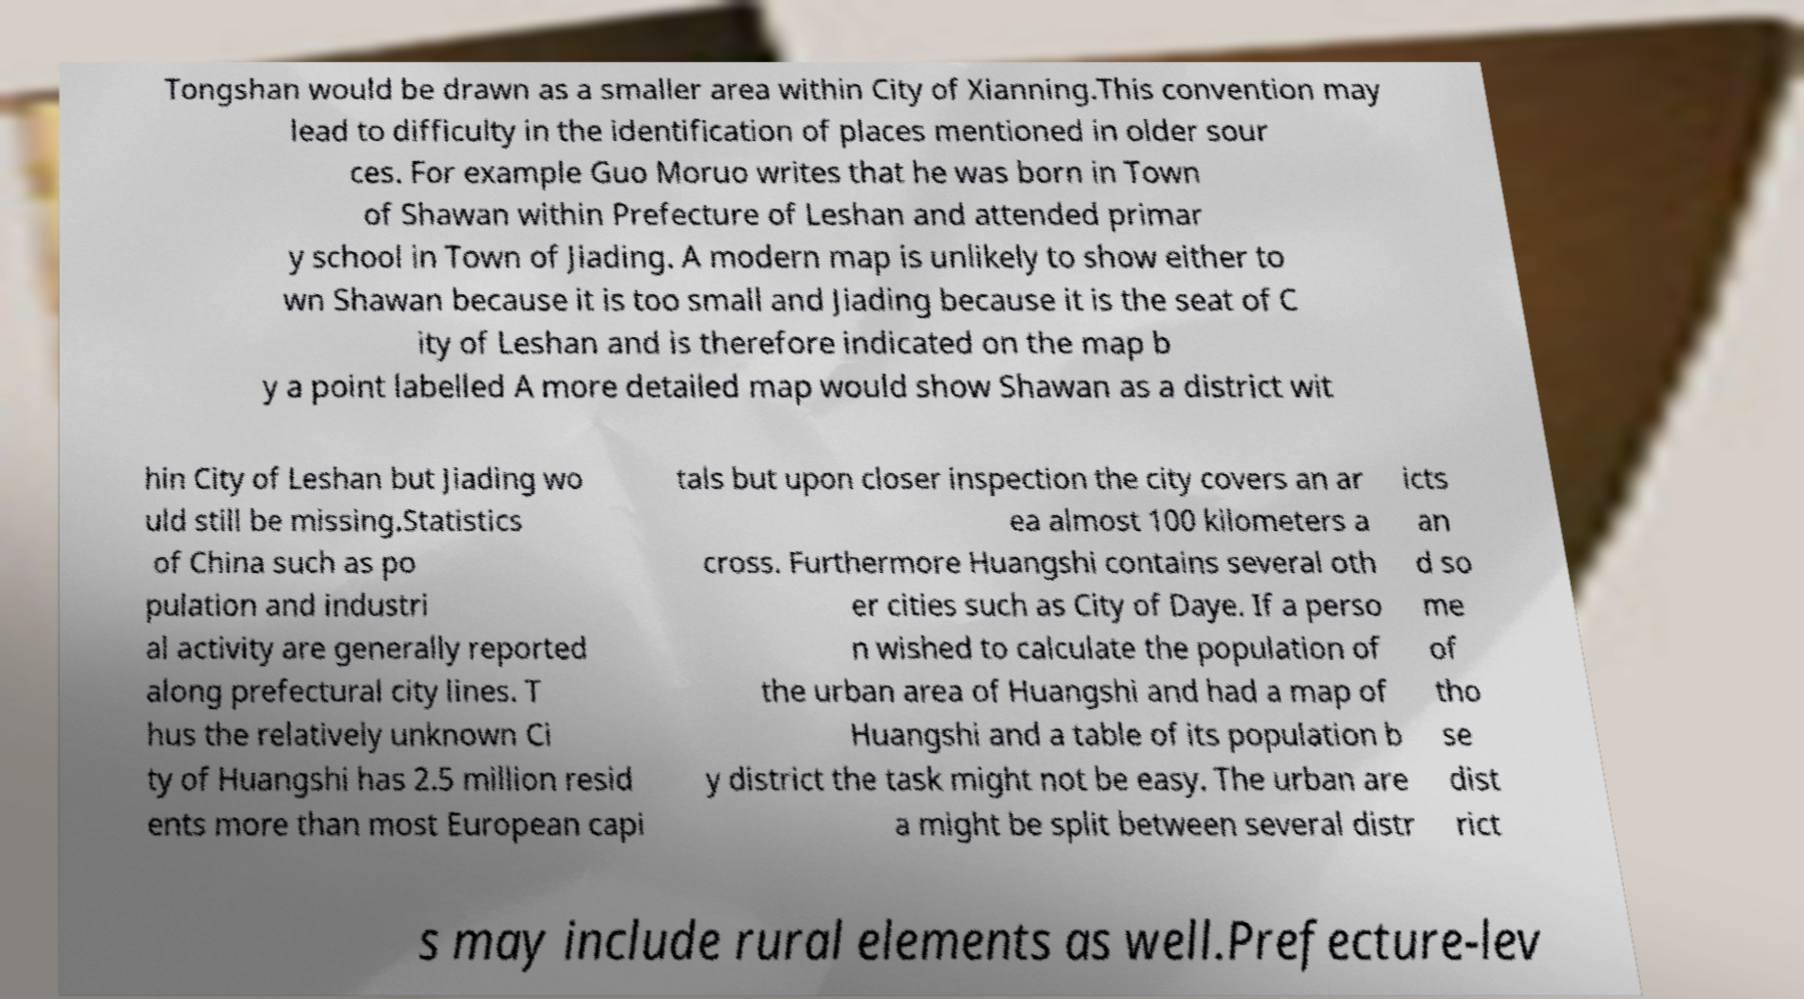I need the written content from this picture converted into text. Can you do that? Tongshan would be drawn as a smaller area within City of Xianning.This convention may lead to difficulty in the identification of places mentioned in older sour ces. For example Guo Moruo writes that he was born in Town of Shawan within Prefecture of Leshan and attended primar y school in Town of Jiading. A modern map is unlikely to show either to wn Shawan because it is too small and Jiading because it is the seat of C ity of Leshan and is therefore indicated on the map b y a point labelled A more detailed map would show Shawan as a district wit hin City of Leshan but Jiading wo uld still be missing.Statistics of China such as po pulation and industri al activity are generally reported along prefectural city lines. T hus the relatively unknown Ci ty of Huangshi has 2.5 million resid ents more than most European capi tals but upon closer inspection the city covers an ar ea almost 100 kilometers a cross. Furthermore Huangshi contains several oth er cities such as City of Daye. If a perso n wished to calculate the population of the urban area of Huangshi and had a map of Huangshi and a table of its population b y district the task might not be easy. The urban are a might be split between several distr icts an d so me of tho se dist rict s may include rural elements as well.Prefecture-lev 